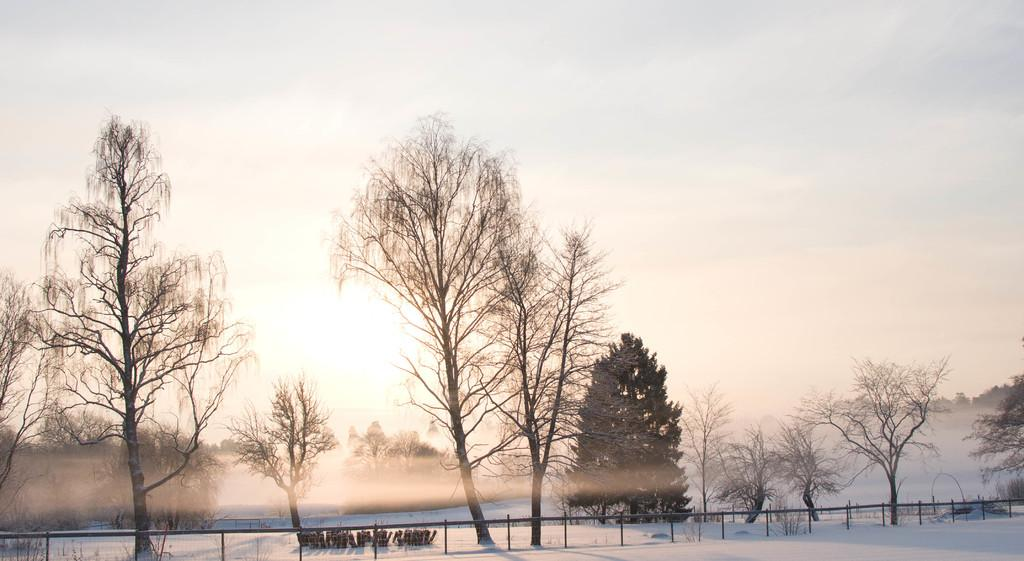What type of vegetation is visible in the image? There are trees with branches and leaves in the image. What type of structure can be seen in the image? There appears to be a fence in the image. What might indicate the season or weather in the image? The presence of snow is suggested in the image. What school do the friends attend in the image? There are no schools or friends present in the image. What type of account is mentioned in the image? There is no mention of any accounts in the image. 